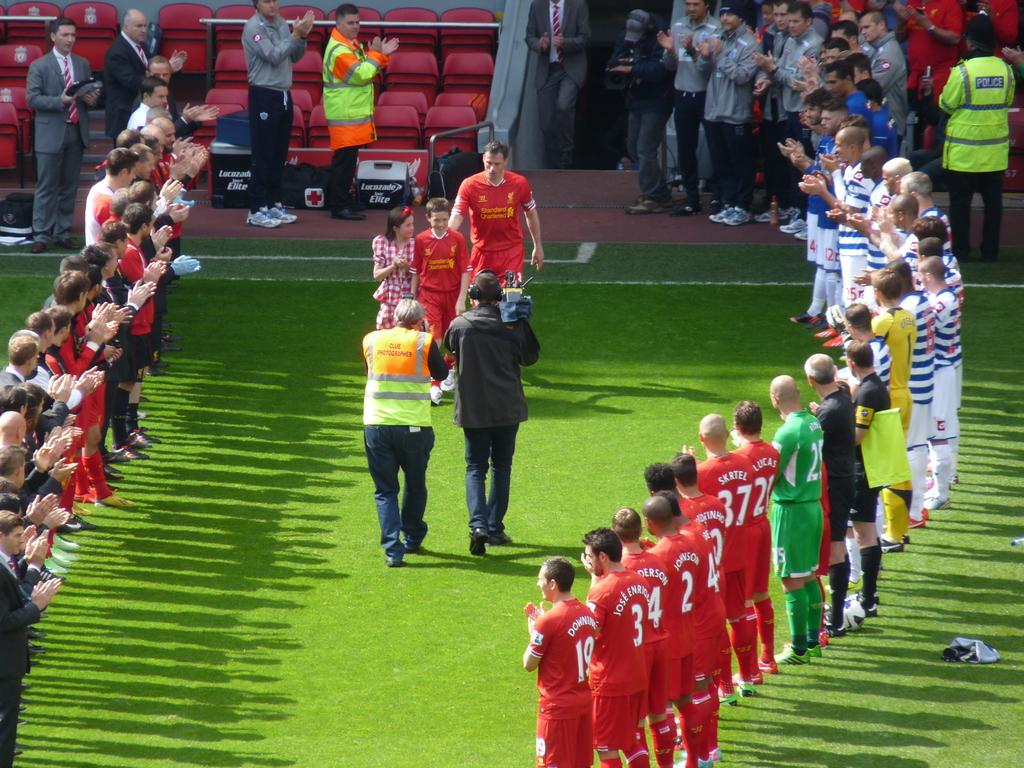<image>
Render a clear and concise summary of the photo. Players are lined up together including numbers 19 and 3. 